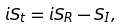Convert formula to latex. <formula><loc_0><loc_0><loc_500><loc_500>i S _ { t } = i S _ { R } - S _ { I } ,</formula> 